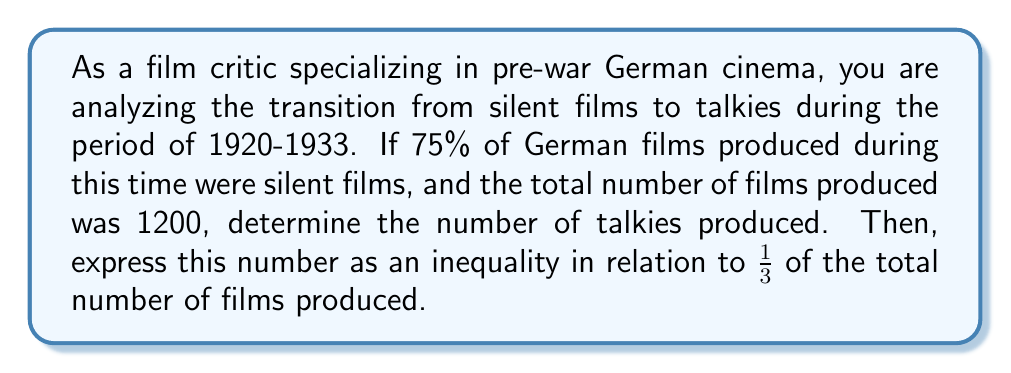Provide a solution to this math problem. Let's approach this step-by-step:

1) First, let's define our variables:
   Let $x$ be the number of talkies produced
   Let $y$ be the number of silent films produced
   Total number of films = 1200

2) We know that 75% of the films were silent. This means:
   $y = 0.75 \times 1200 = 900$ silent films

3) The number of talkies is the total minus the number of silent films:
   $x = 1200 - 900 = 300$ talkies

4) Now, we need to compare this to $\frac{1}{3}$ of the total:
   $\frac{1}{3}$ of 1200 = $\frac{1200}{3} = 400$

5) We can see that 300 is less than 400, so we can express this as an inequality:
   $x < \frac{1200}{3}$

6) Simplifying the right side of the inequality:
   $x < 400$

Therefore, the number of talkies (300) is less than $\frac{1}{3}$ of the total number of films produced.
Answer: The number of talkies produced is 300, and this can be expressed as the inequality:

$$x < 400$$

where $x$ represents the number of talkies produced. 